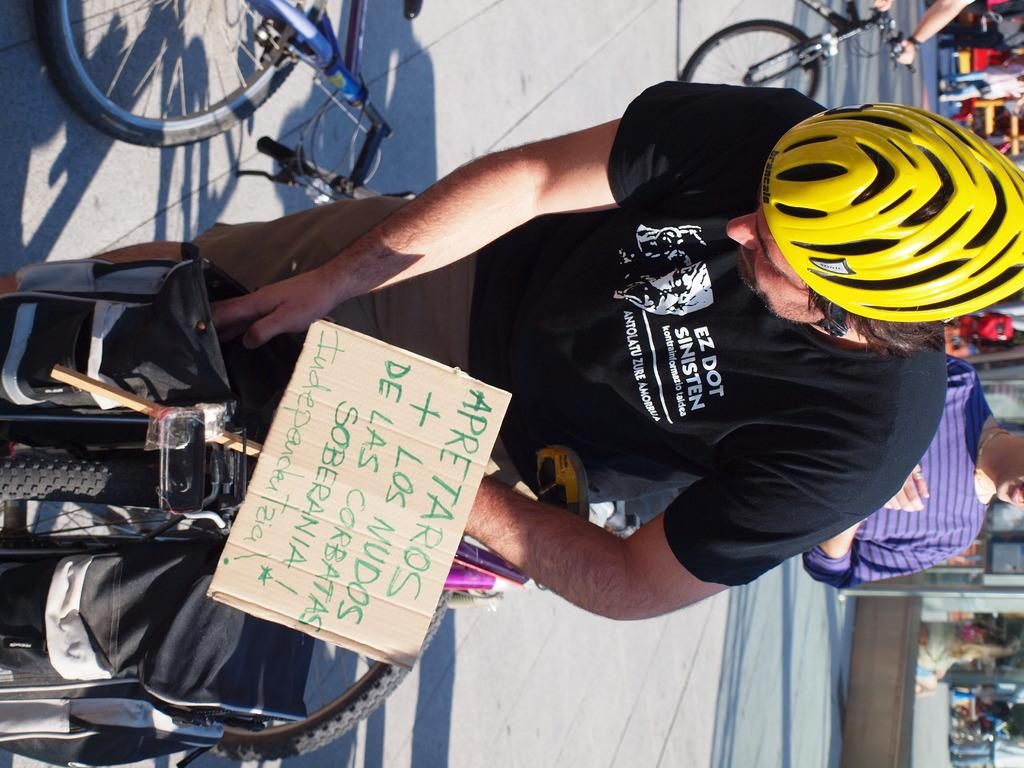<image>
Give a short and clear explanation of the subsequent image. A man is working on a bicycle and is wearing a shirt with the word dot on it. 